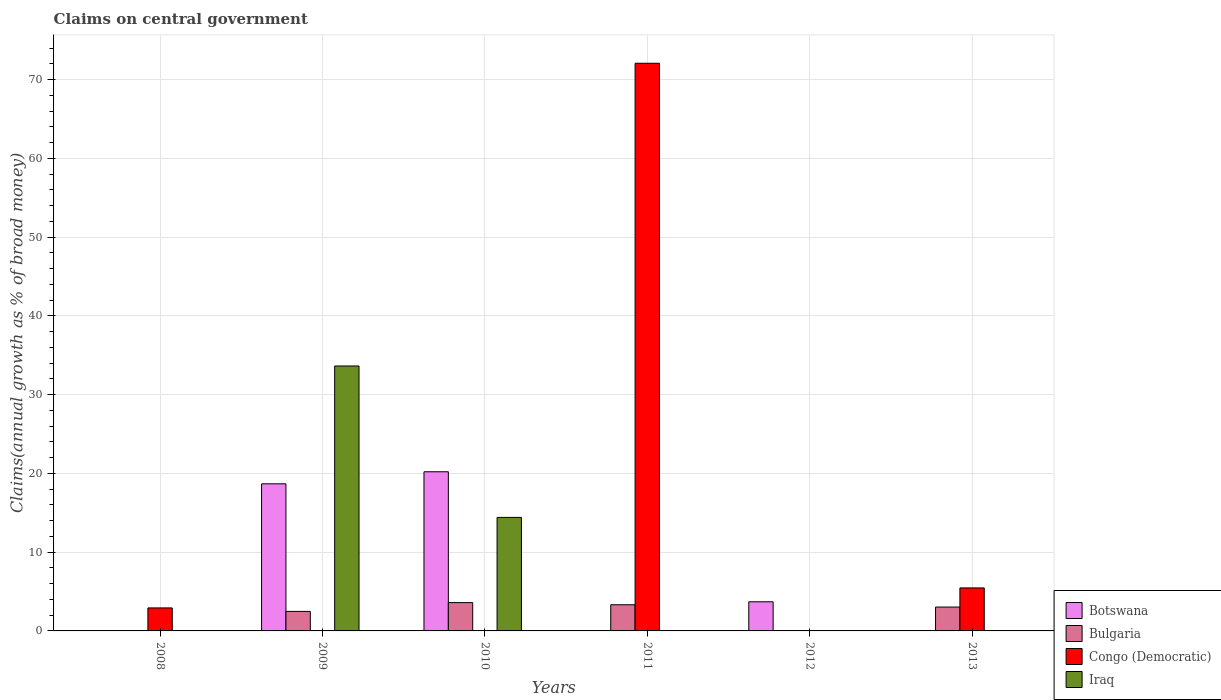How many different coloured bars are there?
Make the answer very short. 4. How many bars are there on the 1st tick from the left?
Your response must be concise. 1. How many bars are there on the 1st tick from the right?
Provide a succinct answer. 2. In how many cases, is the number of bars for a given year not equal to the number of legend labels?
Your answer should be compact. 6. What is the percentage of broad money claimed on centeral government in Botswana in 2010?
Keep it short and to the point. 20.21. Across all years, what is the maximum percentage of broad money claimed on centeral government in Botswana?
Ensure brevity in your answer.  20.21. Across all years, what is the minimum percentage of broad money claimed on centeral government in Botswana?
Offer a very short reply. 0. In which year was the percentage of broad money claimed on centeral government in Congo (Democratic) maximum?
Your answer should be compact. 2011. What is the total percentage of broad money claimed on centeral government in Congo (Democratic) in the graph?
Offer a terse response. 80.45. What is the difference between the percentage of broad money claimed on centeral government in Bulgaria in 2009 and that in 2013?
Offer a very short reply. -0.55. What is the difference between the percentage of broad money claimed on centeral government in Botswana in 2011 and the percentage of broad money claimed on centeral government in Congo (Democratic) in 2013?
Offer a very short reply. -5.46. What is the average percentage of broad money claimed on centeral government in Botswana per year?
Your answer should be compact. 7.1. In how many years, is the percentage of broad money claimed on centeral government in Iraq greater than 12 %?
Ensure brevity in your answer.  2. What is the ratio of the percentage of broad money claimed on centeral government in Botswana in 2009 to that in 2012?
Make the answer very short. 5.05. Is the percentage of broad money claimed on centeral government in Botswana in 2009 less than that in 2010?
Give a very brief answer. Yes. What is the difference between the highest and the second highest percentage of broad money claimed on centeral government in Bulgaria?
Your answer should be compact. 0.27. What is the difference between the highest and the lowest percentage of broad money claimed on centeral government in Congo (Democratic)?
Keep it short and to the point. 72.07. In how many years, is the percentage of broad money claimed on centeral government in Botswana greater than the average percentage of broad money claimed on centeral government in Botswana taken over all years?
Make the answer very short. 2. Is it the case that in every year, the sum of the percentage of broad money claimed on centeral government in Congo (Democratic) and percentage of broad money claimed on centeral government in Botswana is greater than the percentage of broad money claimed on centeral government in Bulgaria?
Your answer should be very brief. Yes. What is the difference between two consecutive major ticks on the Y-axis?
Offer a very short reply. 10. Does the graph contain grids?
Offer a very short reply. Yes. Where does the legend appear in the graph?
Provide a succinct answer. Bottom right. How are the legend labels stacked?
Your answer should be compact. Vertical. What is the title of the graph?
Provide a short and direct response. Claims on central government. What is the label or title of the X-axis?
Give a very brief answer. Years. What is the label or title of the Y-axis?
Your answer should be very brief. Claims(annual growth as % of broad money). What is the Claims(annual growth as % of broad money) in Congo (Democratic) in 2008?
Ensure brevity in your answer.  2.92. What is the Claims(annual growth as % of broad money) in Iraq in 2008?
Provide a short and direct response. 0. What is the Claims(annual growth as % of broad money) of Botswana in 2009?
Provide a short and direct response. 18.68. What is the Claims(annual growth as % of broad money) of Bulgaria in 2009?
Provide a short and direct response. 2.48. What is the Claims(annual growth as % of broad money) in Congo (Democratic) in 2009?
Offer a terse response. 0. What is the Claims(annual growth as % of broad money) of Iraq in 2009?
Offer a very short reply. 33.64. What is the Claims(annual growth as % of broad money) of Botswana in 2010?
Ensure brevity in your answer.  20.21. What is the Claims(annual growth as % of broad money) in Bulgaria in 2010?
Provide a short and direct response. 3.59. What is the Claims(annual growth as % of broad money) of Congo (Democratic) in 2010?
Your response must be concise. 0. What is the Claims(annual growth as % of broad money) in Iraq in 2010?
Offer a terse response. 14.41. What is the Claims(annual growth as % of broad money) in Botswana in 2011?
Provide a succinct answer. 0. What is the Claims(annual growth as % of broad money) in Bulgaria in 2011?
Give a very brief answer. 3.32. What is the Claims(annual growth as % of broad money) in Congo (Democratic) in 2011?
Your answer should be compact. 72.07. What is the Claims(annual growth as % of broad money) of Iraq in 2011?
Your response must be concise. 0. What is the Claims(annual growth as % of broad money) in Botswana in 2012?
Offer a very short reply. 3.7. What is the Claims(annual growth as % of broad money) in Congo (Democratic) in 2012?
Offer a terse response. 0. What is the Claims(annual growth as % of broad money) in Botswana in 2013?
Offer a terse response. 0. What is the Claims(annual growth as % of broad money) in Bulgaria in 2013?
Offer a very short reply. 3.03. What is the Claims(annual growth as % of broad money) of Congo (Democratic) in 2013?
Keep it short and to the point. 5.46. Across all years, what is the maximum Claims(annual growth as % of broad money) of Botswana?
Give a very brief answer. 20.21. Across all years, what is the maximum Claims(annual growth as % of broad money) of Bulgaria?
Provide a short and direct response. 3.59. Across all years, what is the maximum Claims(annual growth as % of broad money) of Congo (Democratic)?
Make the answer very short. 72.07. Across all years, what is the maximum Claims(annual growth as % of broad money) in Iraq?
Make the answer very short. 33.64. Across all years, what is the minimum Claims(annual growth as % of broad money) of Bulgaria?
Give a very brief answer. 0. Across all years, what is the minimum Claims(annual growth as % of broad money) of Iraq?
Ensure brevity in your answer.  0. What is the total Claims(annual growth as % of broad money) in Botswana in the graph?
Provide a succinct answer. 42.58. What is the total Claims(annual growth as % of broad money) of Bulgaria in the graph?
Keep it short and to the point. 12.42. What is the total Claims(annual growth as % of broad money) of Congo (Democratic) in the graph?
Your response must be concise. 80.45. What is the total Claims(annual growth as % of broad money) in Iraq in the graph?
Offer a terse response. 48.05. What is the difference between the Claims(annual growth as % of broad money) in Congo (Democratic) in 2008 and that in 2011?
Offer a very short reply. -69.15. What is the difference between the Claims(annual growth as % of broad money) in Congo (Democratic) in 2008 and that in 2013?
Offer a terse response. -2.54. What is the difference between the Claims(annual growth as % of broad money) of Botswana in 2009 and that in 2010?
Provide a succinct answer. -1.53. What is the difference between the Claims(annual growth as % of broad money) in Bulgaria in 2009 and that in 2010?
Your response must be concise. -1.11. What is the difference between the Claims(annual growth as % of broad money) in Iraq in 2009 and that in 2010?
Your response must be concise. 19.22. What is the difference between the Claims(annual growth as % of broad money) of Bulgaria in 2009 and that in 2011?
Keep it short and to the point. -0.84. What is the difference between the Claims(annual growth as % of broad money) of Botswana in 2009 and that in 2012?
Your answer should be very brief. 14.98. What is the difference between the Claims(annual growth as % of broad money) in Bulgaria in 2009 and that in 2013?
Your answer should be very brief. -0.55. What is the difference between the Claims(annual growth as % of broad money) of Bulgaria in 2010 and that in 2011?
Give a very brief answer. 0.27. What is the difference between the Claims(annual growth as % of broad money) in Botswana in 2010 and that in 2012?
Make the answer very short. 16.51. What is the difference between the Claims(annual growth as % of broad money) of Bulgaria in 2010 and that in 2013?
Your answer should be compact. 0.56. What is the difference between the Claims(annual growth as % of broad money) in Bulgaria in 2011 and that in 2013?
Ensure brevity in your answer.  0.29. What is the difference between the Claims(annual growth as % of broad money) in Congo (Democratic) in 2011 and that in 2013?
Provide a succinct answer. 66.61. What is the difference between the Claims(annual growth as % of broad money) of Congo (Democratic) in 2008 and the Claims(annual growth as % of broad money) of Iraq in 2009?
Keep it short and to the point. -30.72. What is the difference between the Claims(annual growth as % of broad money) of Congo (Democratic) in 2008 and the Claims(annual growth as % of broad money) of Iraq in 2010?
Provide a short and direct response. -11.49. What is the difference between the Claims(annual growth as % of broad money) in Botswana in 2009 and the Claims(annual growth as % of broad money) in Bulgaria in 2010?
Your response must be concise. 15.08. What is the difference between the Claims(annual growth as % of broad money) of Botswana in 2009 and the Claims(annual growth as % of broad money) of Iraq in 2010?
Your answer should be compact. 4.26. What is the difference between the Claims(annual growth as % of broad money) of Bulgaria in 2009 and the Claims(annual growth as % of broad money) of Iraq in 2010?
Ensure brevity in your answer.  -11.93. What is the difference between the Claims(annual growth as % of broad money) in Botswana in 2009 and the Claims(annual growth as % of broad money) in Bulgaria in 2011?
Give a very brief answer. 15.35. What is the difference between the Claims(annual growth as % of broad money) in Botswana in 2009 and the Claims(annual growth as % of broad money) in Congo (Democratic) in 2011?
Provide a short and direct response. -53.39. What is the difference between the Claims(annual growth as % of broad money) in Bulgaria in 2009 and the Claims(annual growth as % of broad money) in Congo (Democratic) in 2011?
Keep it short and to the point. -69.59. What is the difference between the Claims(annual growth as % of broad money) of Botswana in 2009 and the Claims(annual growth as % of broad money) of Bulgaria in 2013?
Offer a terse response. 15.65. What is the difference between the Claims(annual growth as % of broad money) in Botswana in 2009 and the Claims(annual growth as % of broad money) in Congo (Democratic) in 2013?
Ensure brevity in your answer.  13.22. What is the difference between the Claims(annual growth as % of broad money) in Bulgaria in 2009 and the Claims(annual growth as % of broad money) in Congo (Democratic) in 2013?
Your response must be concise. -2.98. What is the difference between the Claims(annual growth as % of broad money) of Botswana in 2010 and the Claims(annual growth as % of broad money) of Bulgaria in 2011?
Offer a very short reply. 16.89. What is the difference between the Claims(annual growth as % of broad money) in Botswana in 2010 and the Claims(annual growth as % of broad money) in Congo (Democratic) in 2011?
Your answer should be very brief. -51.86. What is the difference between the Claims(annual growth as % of broad money) in Bulgaria in 2010 and the Claims(annual growth as % of broad money) in Congo (Democratic) in 2011?
Provide a short and direct response. -68.48. What is the difference between the Claims(annual growth as % of broad money) of Botswana in 2010 and the Claims(annual growth as % of broad money) of Bulgaria in 2013?
Your response must be concise. 17.18. What is the difference between the Claims(annual growth as % of broad money) of Botswana in 2010 and the Claims(annual growth as % of broad money) of Congo (Democratic) in 2013?
Provide a succinct answer. 14.75. What is the difference between the Claims(annual growth as % of broad money) of Bulgaria in 2010 and the Claims(annual growth as % of broad money) of Congo (Democratic) in 2013?
Your response must be concise. -1.87. What is the difference between the Claims(annual growth as % of broad money) in Bulgaria in 2011 and the Claims(annual growth as % of broad money) in Congo (Democratic) in 2013?
Provide a succinct answer. -2.14. What is the difference between the Claims(annual growth as % of broad money) in Botswana in 2012 and the Claims(annual growth as % of broad money) in Bulgaria in 2013?
Your answer should be compact. 0.67. What is the difference between the Claims(annual growth as % of broad money) of Botswana in 2012 and the Claims(annual growth as % of broad money) of Congo (Democratic) in 2013?
Your response must be concise. -1.76. What is the average Claims(annual growth as % of broad money) of Botswana per year?
Offer a very short reply. 7.1. What is the average Claims(annual growth as % of broad money) of Bulgaria per year?
Provide a succinct answer. 2.07. What is the average Claims(annual growth as % of broad money) in Congo (Democratic) per year?
Ensure brevity in your answer.  13.41. What is the average Claims(annual growth as % of broad money) in Iraq per year?
Ensure brevity in your answer.  8.01. In the year 2009, what is the difference between the Claims(annual growth as % of broad money) in Botswana and Claims(annual growth as % of broad money) in Bulgaria?
Give a very brief answer. 16.2. In the year 2009, what is the difference between the Claims(annual growth as % of broad money) in Botswana and Claims(annual growth as % of broad money) in Iraq?
Provide a succinct answer. -14.96. In the year 2009, what is the difference between the Claims(annual growth as % of broad money) of Bulgaria and Claims(annual growth as % of broad money) of Iraq?
Offer a terse response. -31.16. In the year 2010, what is the difference between the Claims(annual growth as % of broad money) of Botswana and Claims(annual growth as % of broad money) of Bulgaria?
Your response must be concise. 16.61. In the year 2010, what is the difference between the Claims(annual growth as % of broad money) in Botswana and Claims(annual growth as % of broad money) in Iraq?
Give a very brief answer. 5.79. In the year 2010, what is the difference between the Claims(annual growth as % of broad money) of Bulgaria and Claims(annual growth as % of broad money) of Iraq?
Your response must be concise. -10.82. In the year 2011, what is the difference between the Claims(annual growth as % of broad money) in Bulgaria and Claims(annual growth as % of broad money) in Congo (Democratic)?
Offer a very short reply. -68.75. In the year 2013, what is the difference between the Claims(annual growth as % of broad money) in Bulgaria and Claims(annual growth as % of broad money) in Congo (Democratic)?
Ensure brevity in your answer.  -2.43. What is the ratio of the Claims(annual growth as % of broad money) of Congo (Democratic) in 2008 to that in 2011?
Give a very brief answer. 0.04. What is the ratio of the Claims(annual growth as % of broad money) of Congo (Democratic) in 2008 to that in 2013?
Your response must be concise. 0.53. What is the ratio of the Claims(annual growth as % of broad money) of Botswana in 2009 to that in 2010?
Make the answer very short. 0.92. What is the ratio of the Claims(annual growth as % of broad money) in Bulgaria in 2009 to that in 2010?
Keep it short and to the point. 0.69. What is the ratio of the Claims(annual growth as % of broad money) in Iraq in 2009 to that in 2010?
Your answer should be compact. 2.33. What is the ratio of the Claims(annual growth as % of broad money) of Bulgaria in 2009 to that in 2011?
Your answer should be very brief. 0.75. What is the ratio of the Claims(annual growth as % of broad money) of Botswana in 2009 to that in 2012?
Provide a short and direct response. 5.05. What is the ratio of the Claims(annual growth as % of broad money) of Bulgaria in 2009 to that in 2013?
Make the answer very short. 0.82. What is the ratio of the Claims(annual growth as % of broad money) in Bulgaria in 2010 to that in 2011?
Provide a short and direct response. 1.08. What is the ratio of the Claims(annual growth as % of broad money) in Botswana in 2010 to that in 2012?
Your answer should be compact. 5.46. What is the ratio of the Claims(annual growth as % of broad money) of Bulgaria in 2010 to that in 2013?
Offer a very short reply. 1.19. What is the ratio of the Claims(annual growth as % of broad money) in Bulgaria in 2011 to that in 2013?
Your answer should be compact. 1.1. What is the ratio of the Claims(annual growth as % of broad money) of Congo (Democratic) in 2011 to that in 2013?
Provide a short and direct response. 13.2. What is the difference between the highest and the second highest Claims(annual growth as % of broad money) in Botswana?
Keep it short and to the point. 1.53. What is the difference between the highest and the second highest Claims(annual growth as % of broad money) in Bulgaria?
Keep it short and to the point. 0.27. What is the difference between the highest and the second highest Claims(annual growth as % of broad money) in Congo (Democratic)?
Your answer should be very brief. 66.61. What is the difference between the highest and the lowest Claims(annual growth as % of broad money) in Botswana?
Make the answer very short. 20.21. What is the difference between the highest and the lowest Claims(annual growth as % of broad money) in Bulgaria?
Make the answer very short. 3.59. What is the difference between the highest and the lowest Claims(annual growth as % of broad money) in Congo (Democratic)?
Keep it short and to the point. 72.07. What is the difference between the highest and the lowest Claims(annual growth as % of broad money) in Iraq?
Your answer should be very brief. 33.64. 